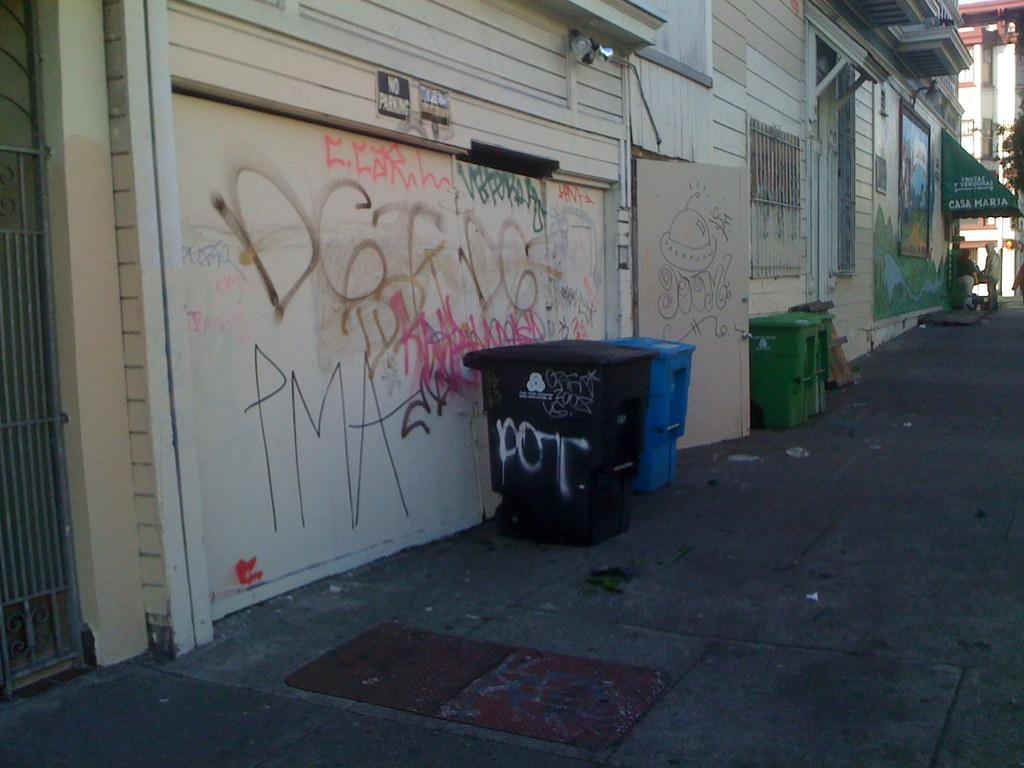Provide a one-sentence caption for the provided image. Black garbage can with the word POT on it. 